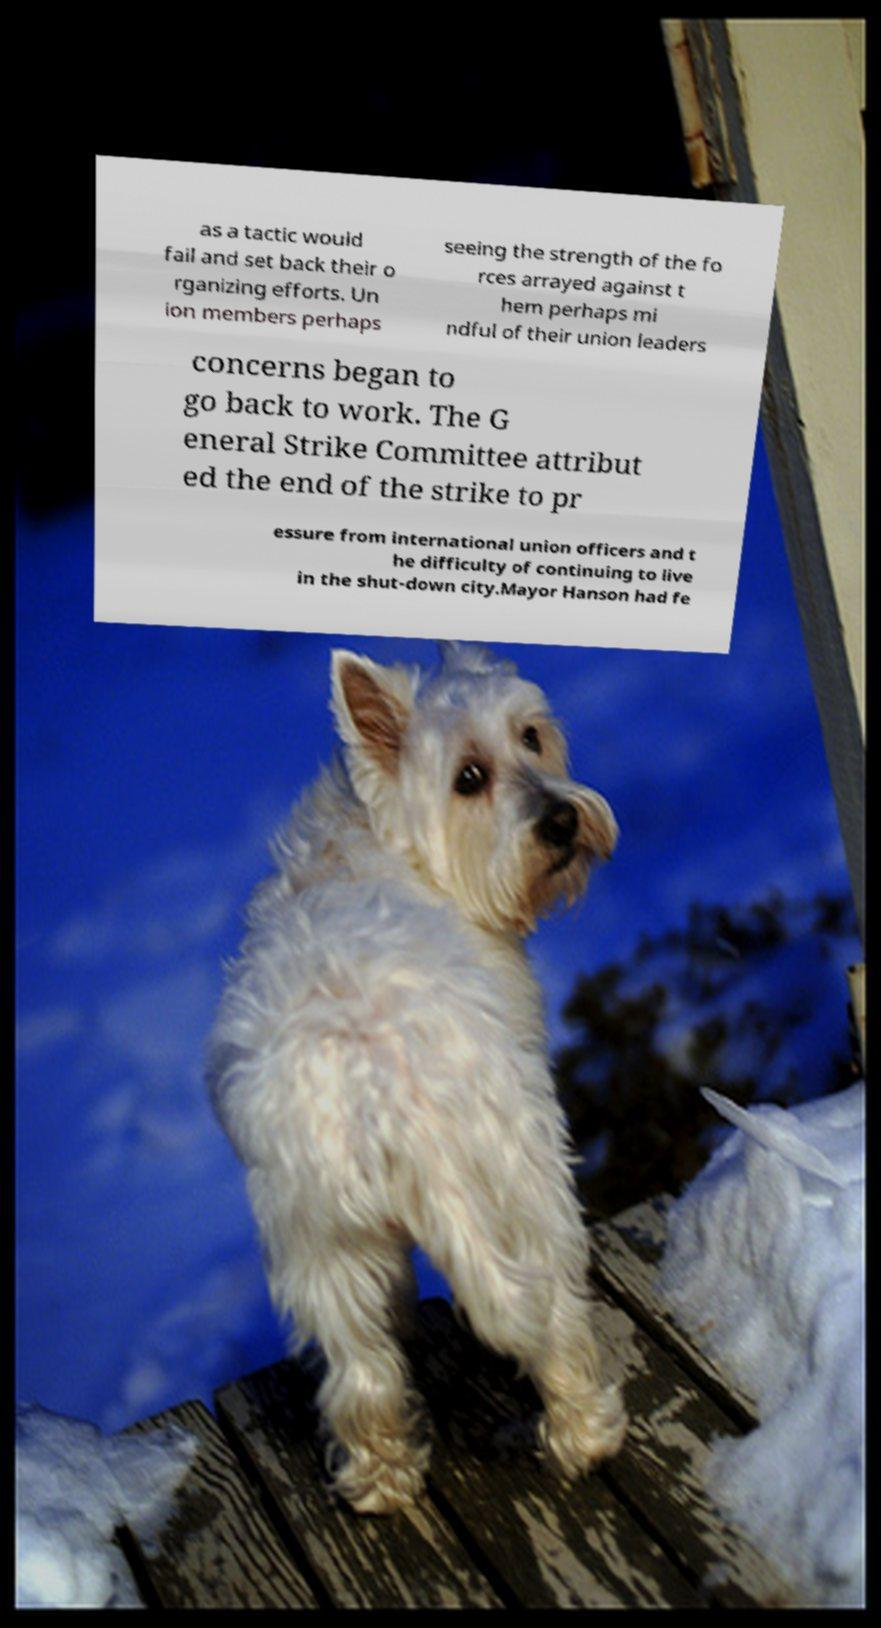Could you extract and type out the text from this image? as a tactic would fail and set back their o rganizing efforts. Un ion members perhaps seeing the strength of the fo rces arrayed against t hem perhaps mi ndful of their union leaders concerns began to go back to work. The G eneral Strike Committee attribut ed the end of the strike to pr essure from international union officers and t he difficulty of continuing to live in the shut-down city.Mayor Hanson had fe 